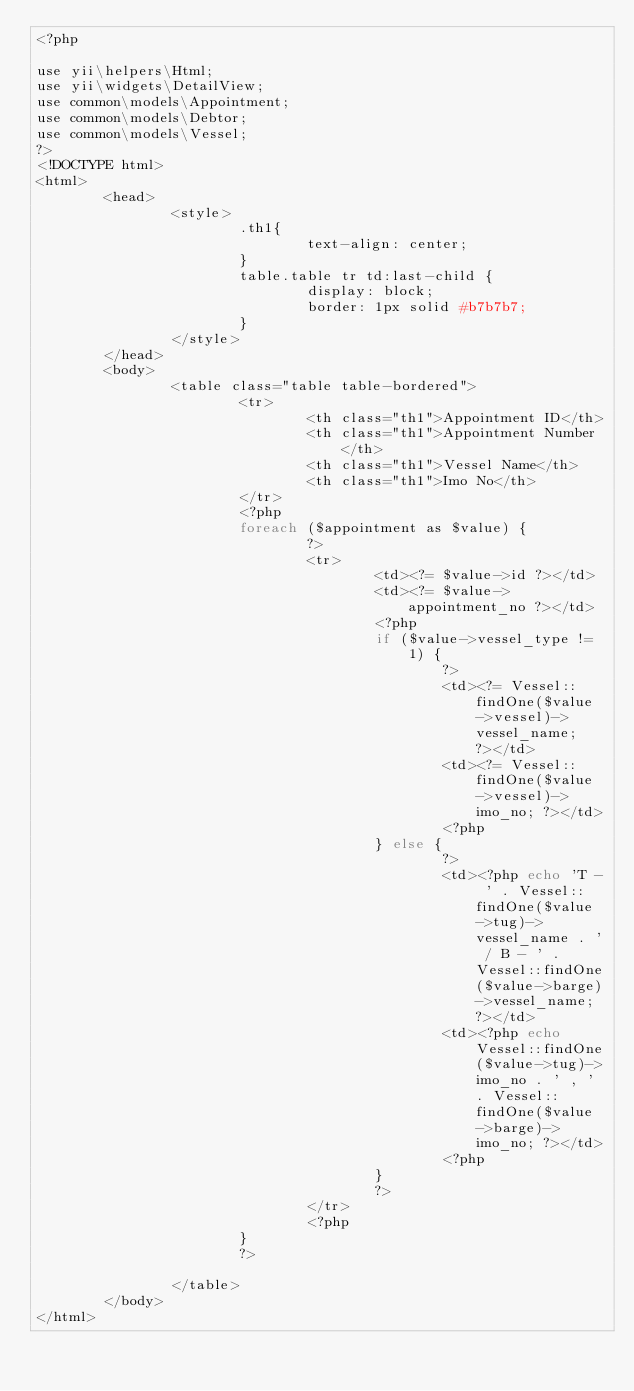<code> <loc_0><loc_0><loc_500><loc_500><_PHP_><?php

use yii\helpers\Html;
use yii\widgets\DetailView;
use common\models\Appointment;
use common\models\Debtor;
use common\models\Vessel;
?>
<!DOCTYPE html>
<html>
        <head>
                <style>
                        .th1{
                                text-align: center;
                        }
                        table.table tr td:last-child {
                                display: block;
                                border: 1px solid #b7b7b7;
                        }
                </style>
        </head>
        <body>
                <table class="table table-bordered">
                        <tr>
                                <th class="th1">Appointment ID</th>
                                <th class="th1">Appointment Number</th>
                                <th class="th1">Vessel Name</th>
                                <th class="th1">Imo No</th>
                        </tr>
                        <?php
                        foreach ($appointment as $value) {
                                ?>
                                <tr>
                                        <td><?= $value->id ?></td>
                                        <td><?= $value->appointment_no ?></td>
                                        <?php
                                        if ($value->vessel_type != 1) {
                                                ?>
                                                <td><?= Vessel::findOne($value->vessel)->vessel_name; ?></td>
                                                <td><?= Vessel::findOne($value->vessel)->imo_no; ?></td>
                                                <?php
                                        } else {
                                                ?>
                                                <td><?php echo 'T - ' . Vessel::findOne($value->tug)->vessel_name . ' / B - ' . Vessel::findOne($value->barge)->vessel_name; ?></td>
                                                <td><?php echo Vessel::findOne($value->tug)->imo_no . ' , ' . Vessel::findOne($value->barge)->imo_no; ?></td>
                                                <?php
                                        }
                                        ?>
                                </tr>
                                <?php
                        }
                        ?>

                </table>
        </body>
</html>

</code> 